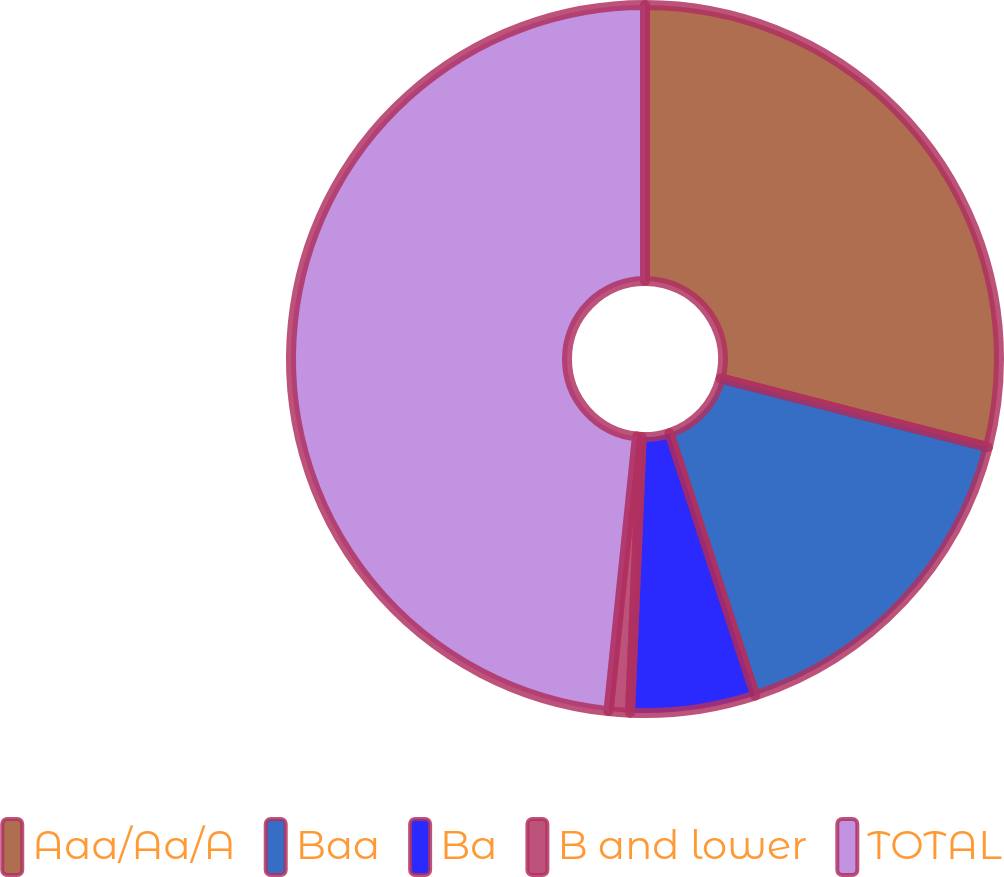Convert chart. <chart><loc_0><loc_0><loc_500><loc_500><pie_chart><fcel>Aaa/Aa/A<fcel>Baa<fcel>Ba<fcel>B and lower<fcel>TOTAL<nl><fcel>29.01%<fcel>15.96%<fcel>5.71%<fcel>0.97%<fcel>48.36%<nl></chart> 